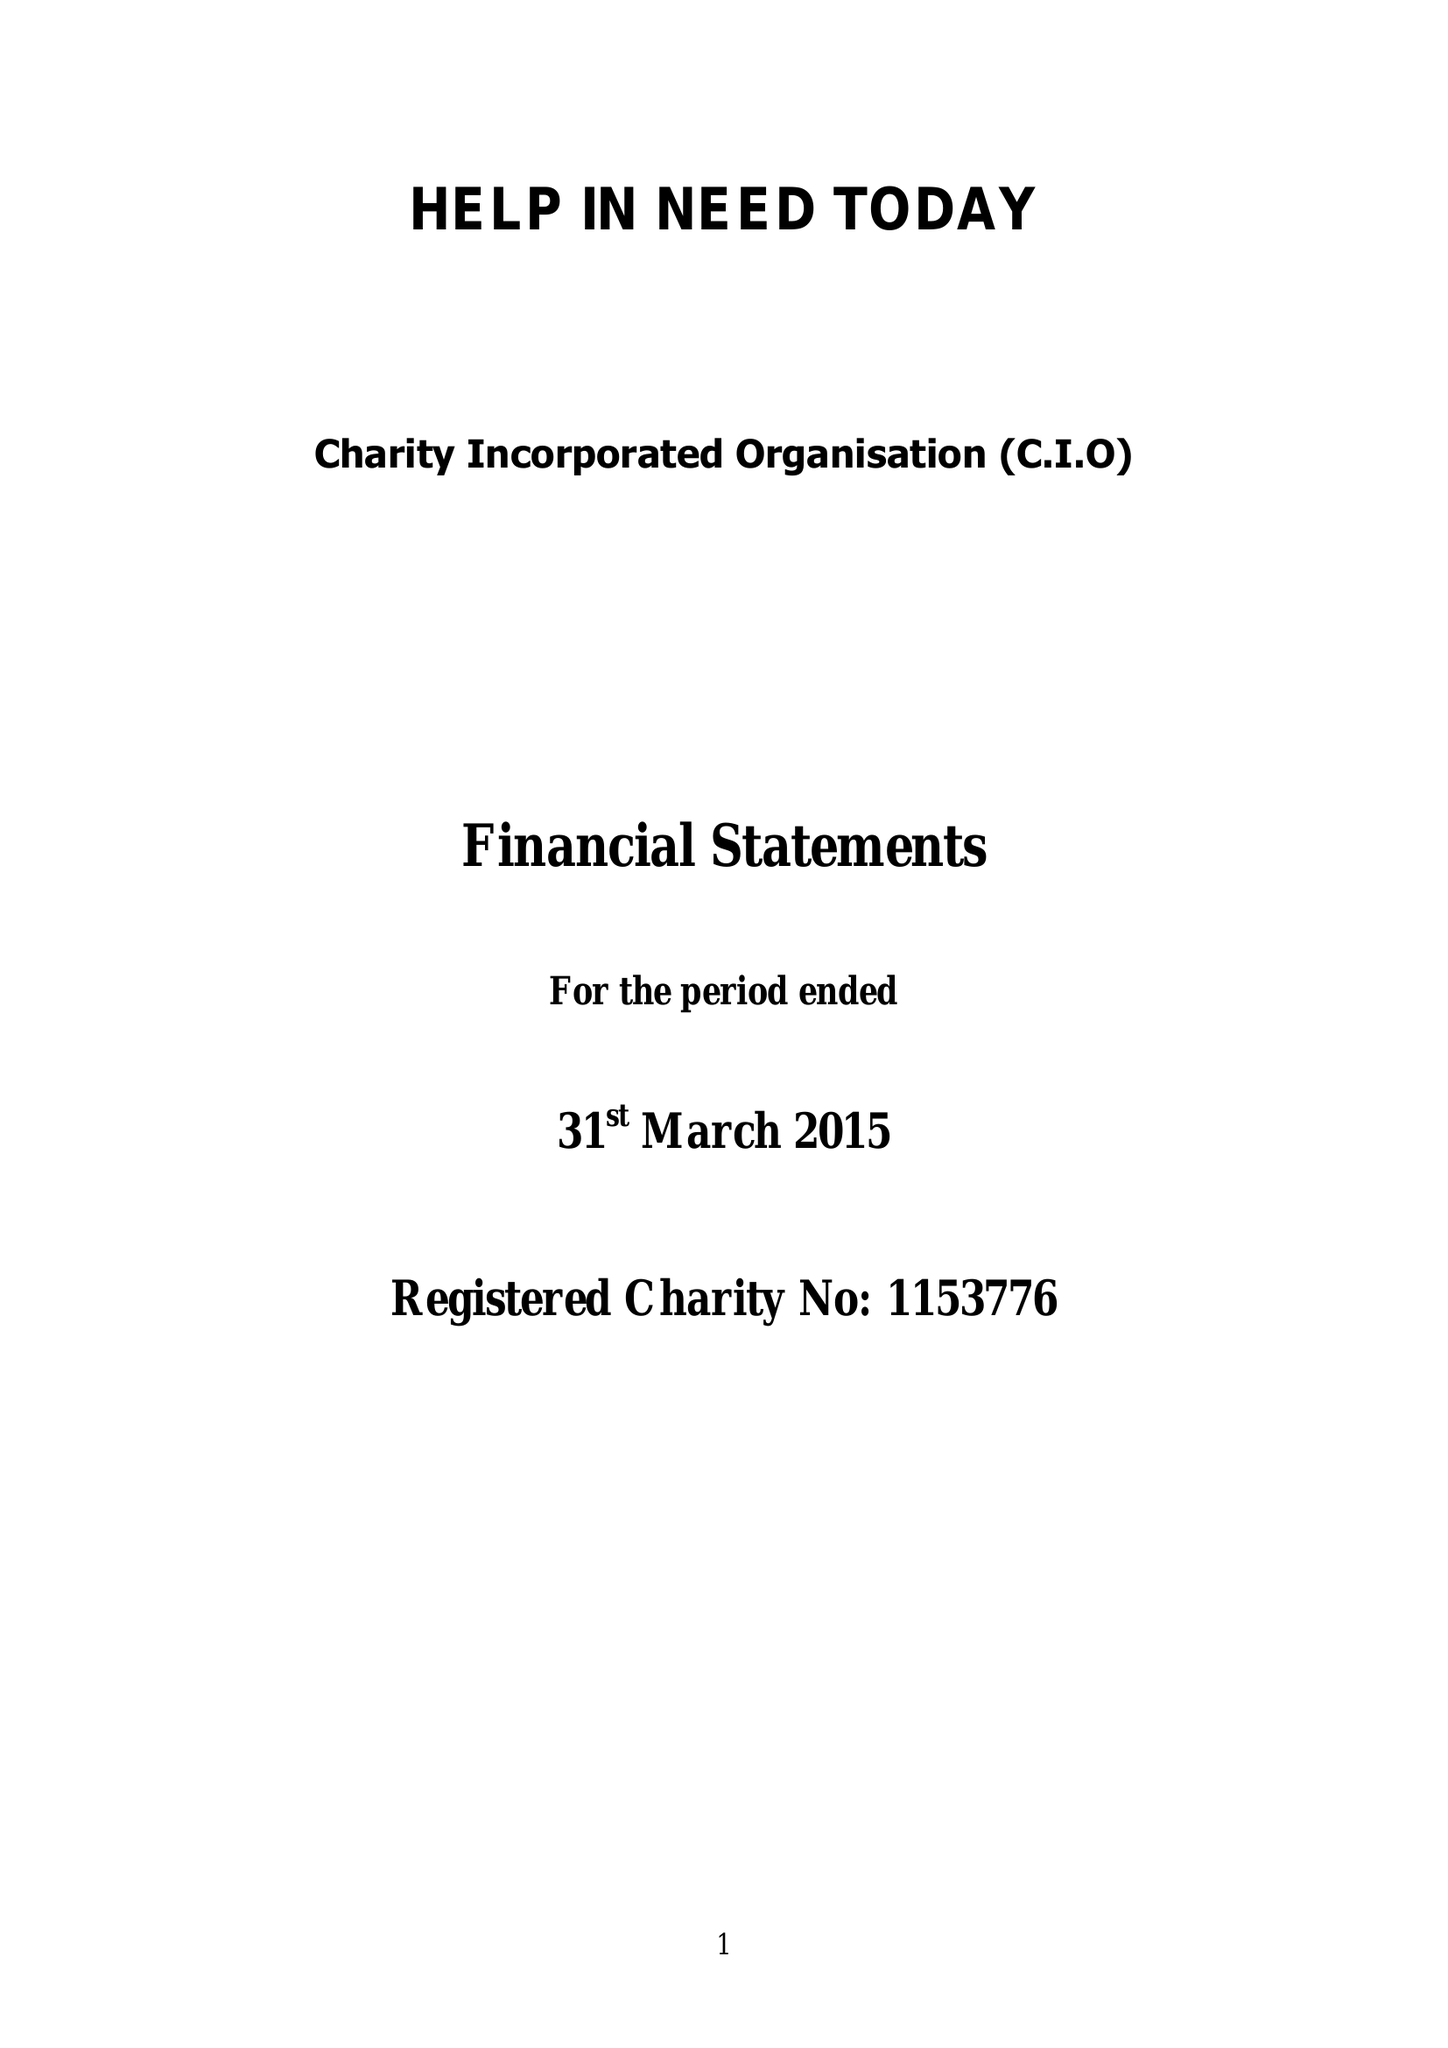What is the value for the report_date?
Answer the question using a single word or phrase. 2015-03-31 